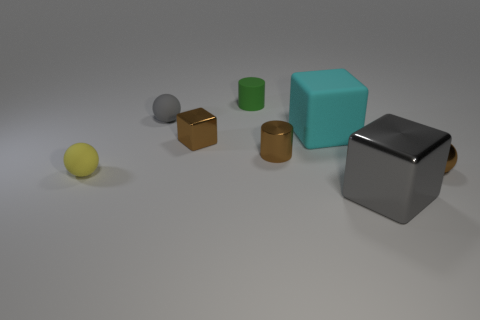Add 1 large gray things. How many objects exist? 9 Subtract all cylinders. How many objects are left? 6 Subtract all shiny objects. Subtract all green metallic blocks. How many objects are left? 4 Add 6 tiny balls. How many tiny balls are left? 9 Add 3 cyan blocks. How many cyan blocks exist? 4 Subtract 0 green cubes. How many objects are left? 8 